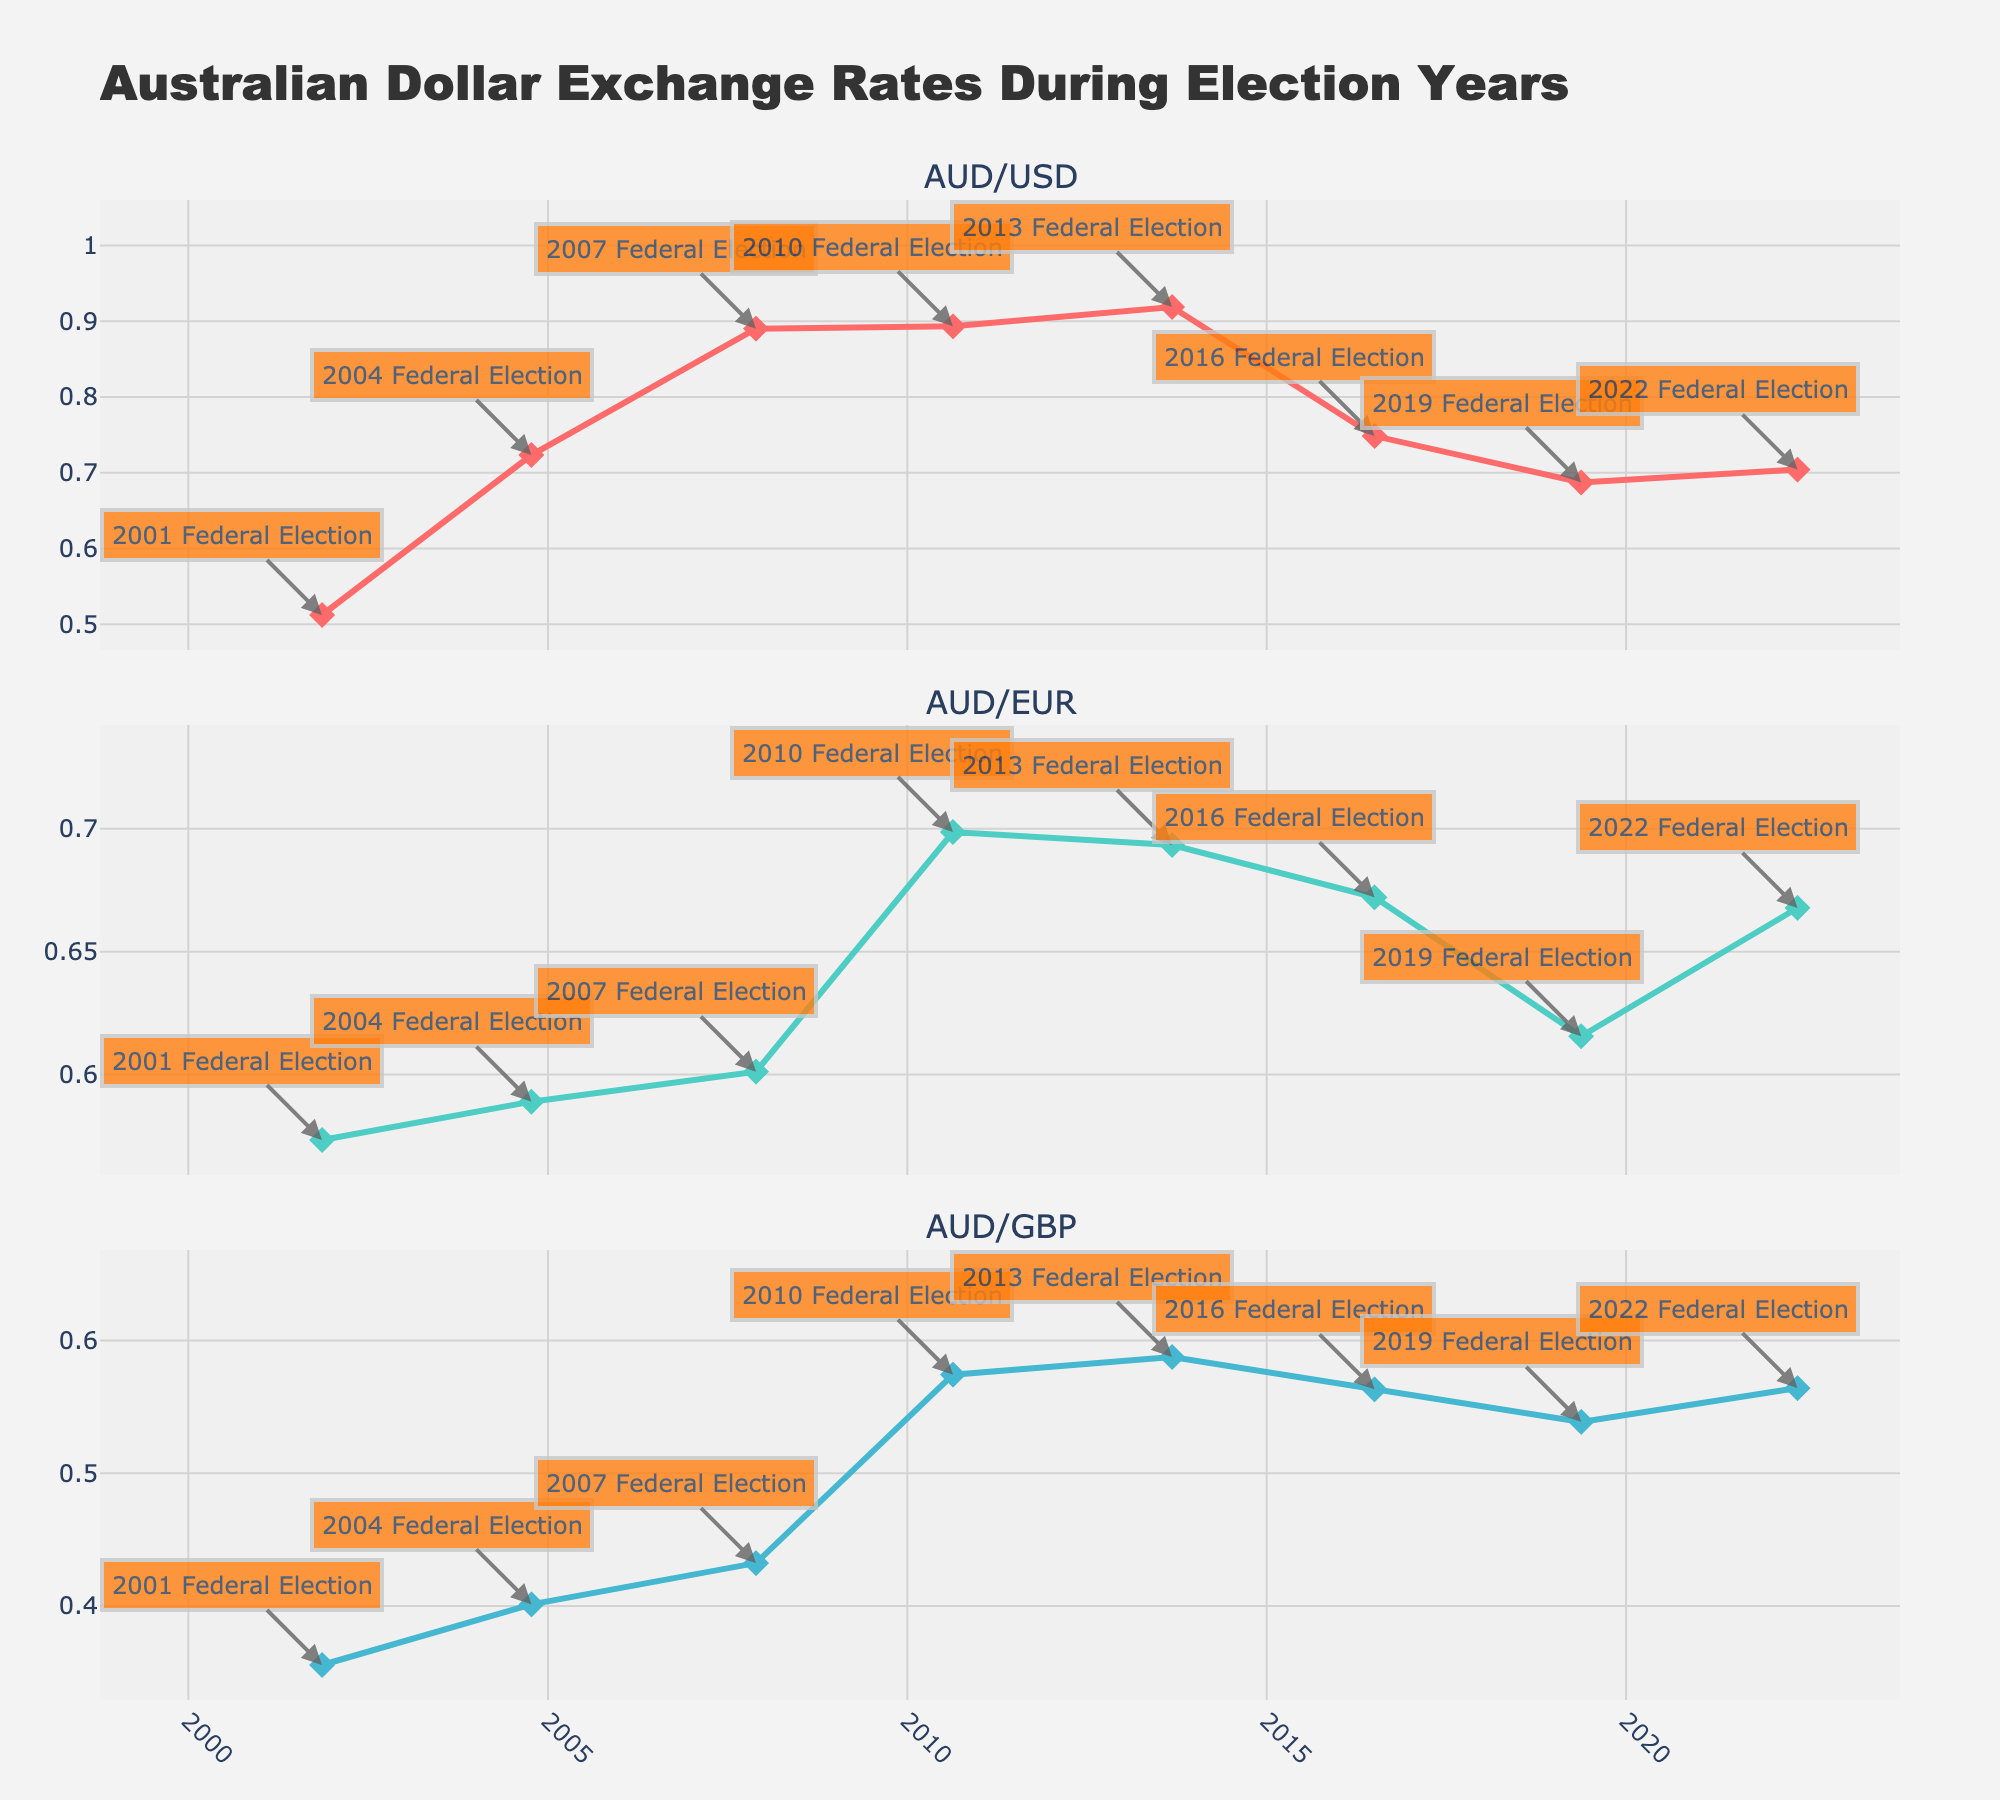What is the title of the figure? The title is located at the top of the figure and reads: "Australian Dollar Exchange Rates During Election Years."
Answer: Australian Dollar Exchange Rates During Election Years Which currency saw an increase in its exchange rate against the Australian Dollar from 2016 to 2019? By observing the three subplot lines from 2016 to 2019, only the AUD/USD exchange rate shows a decrease (indicating the Australian Dollar weakened), while others remain unchanged or fluctuate slightly.
Answer: None What is the lowest exchange rate for AUD/USD throughout the election years? The lowest point on the AUD/USD line is in 2001, where the exchange rate is 0.5123.
Answer: 0.5123 Between AUD/EUR and AUD/GBP, which currency shows a more consistent exchange rate over the years? Observing the line plots for both currencies in their respective subplots, AUD/EUR shows fewer fluctuations compared to AUD/GBP, implying more consistency.
Answer: AUD/EUR In what year did the AUD/USD exchange rate peak, and what was its value? Checking the highest point in the AUD/USD subplot, the peak occurred in 2013 with a value of 0.9187.
Answer: 2013, 0.9187 How did the AUD/EUR exchange rate change between the 2010 and 2013 elections? By comparing the points at 2010 and 2013 on the AUD/EUR subplot, the rate decreased slightly from 0.6987 to 0.6934.
Answer: Decreased Which subplot shows the greatest change in exchange rates over the covered years? Observing the lines, the AUD/USD subplot shows the largest fluctuation range, starting from 0.5123 in 2001 to 0.9187 in 2013, indicating the greatest change.
Answer: AUD/USD Did the AUD/GBP exchange rate increase or decrease between the 2007 and 2010 elections, and by how much? By comparing 2007 and 2010 points on the AUD/GBP subplot, it increased from 0.4323 to 0.5743. The difference is 0.5743 - 0.4323 = 0.142.
Answer: Increased by 0.142 How many total data points are plotted in each subplot? Counting the data points across the election years for each subplot, there are eight data points in each line plot.
Answer: 8 Which election year had the highest AUD/GBP exchange rate, and what was its value? Checking the highest point in the AUD/GBP subplot, the peak occurred in 2013 with a value of 0.5876.
Answer: 2013, 0.5876 